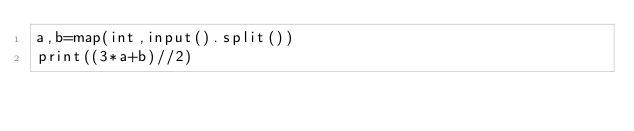<code> <loc_0><loc_0><loc_500><loc_500><_Python_>a,b=map(int,input().split())
print((3*a+b)//2)</code> 